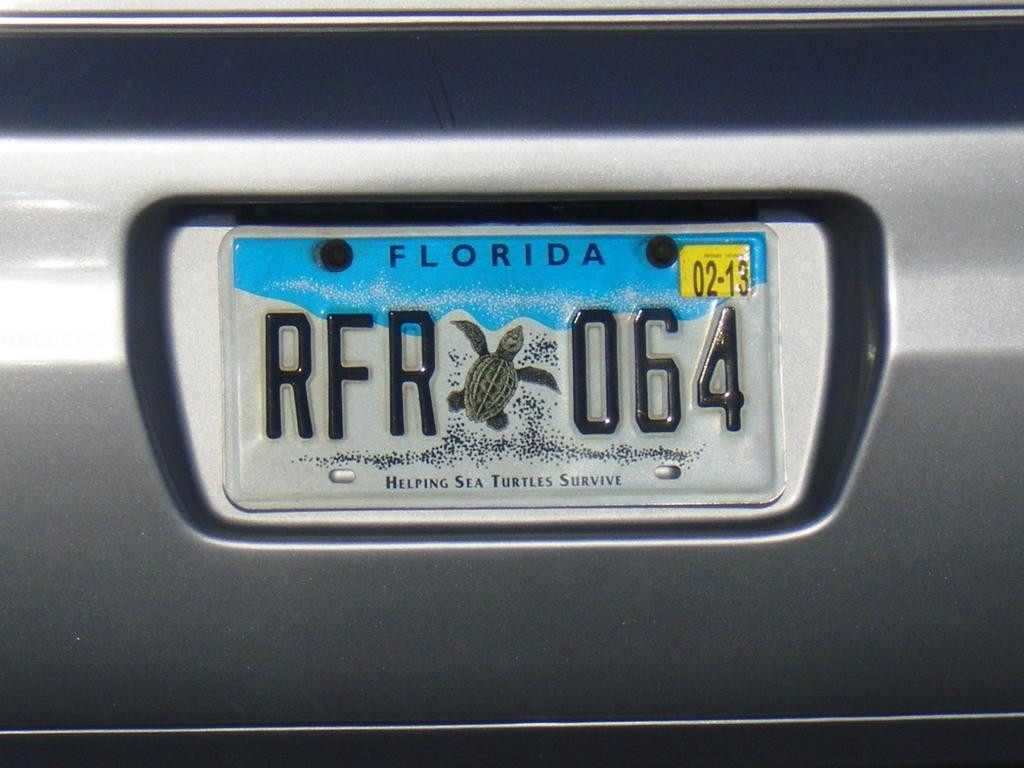<image>
Render a clear and concise summary of the photo. White and blue Florida license plate which says "RFR064". 